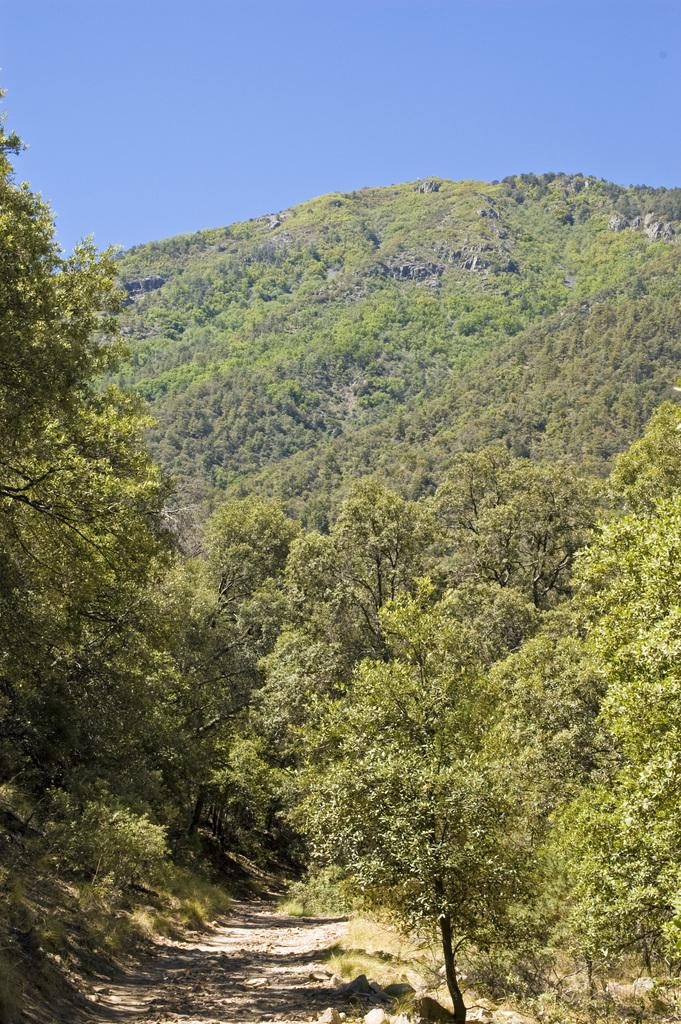What type of vegetation can be seen in the image? There are trees in the image. What geographical feature is present in the image? There is a mountain in the image. What part of the natural environment is visible at the top of the image? The sky is visible at the top of the image. What part of the natural environment is visible at the bottom of the image? The land is visible at the bottom of the image. Can you see any fairies flying around the trees in the image? There are no fairies present in the image; it only features trees, a mountain, the sky, and the land. 